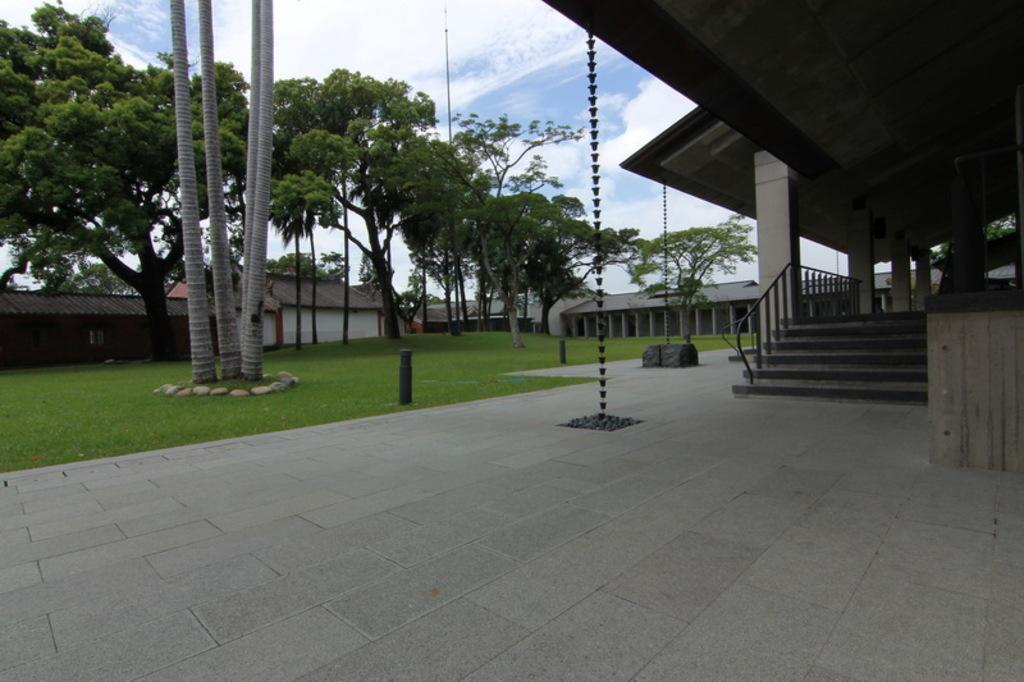What can be seen on the right side of the image? There are stairs on the right side of the image. What is located on the left side of the image? There are trees on the left side of the image. What type of vegetation is visible in the image? There is grass visible in the image. How many pizzas are being served at the cemetery in the image? There is no cemetery or pizzas present in the image. Where is the faucet located in the image? There is no faucet present in the image. 